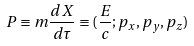Convert formula to latex. <formula><loc_0><loc_0><loc_500><loc_500>P \equiv m \frac { d X } { d \tau } \equiv ( \frac { E } { c } ; p _ { x } , p _ { y } , p _ { z } )</formula> 